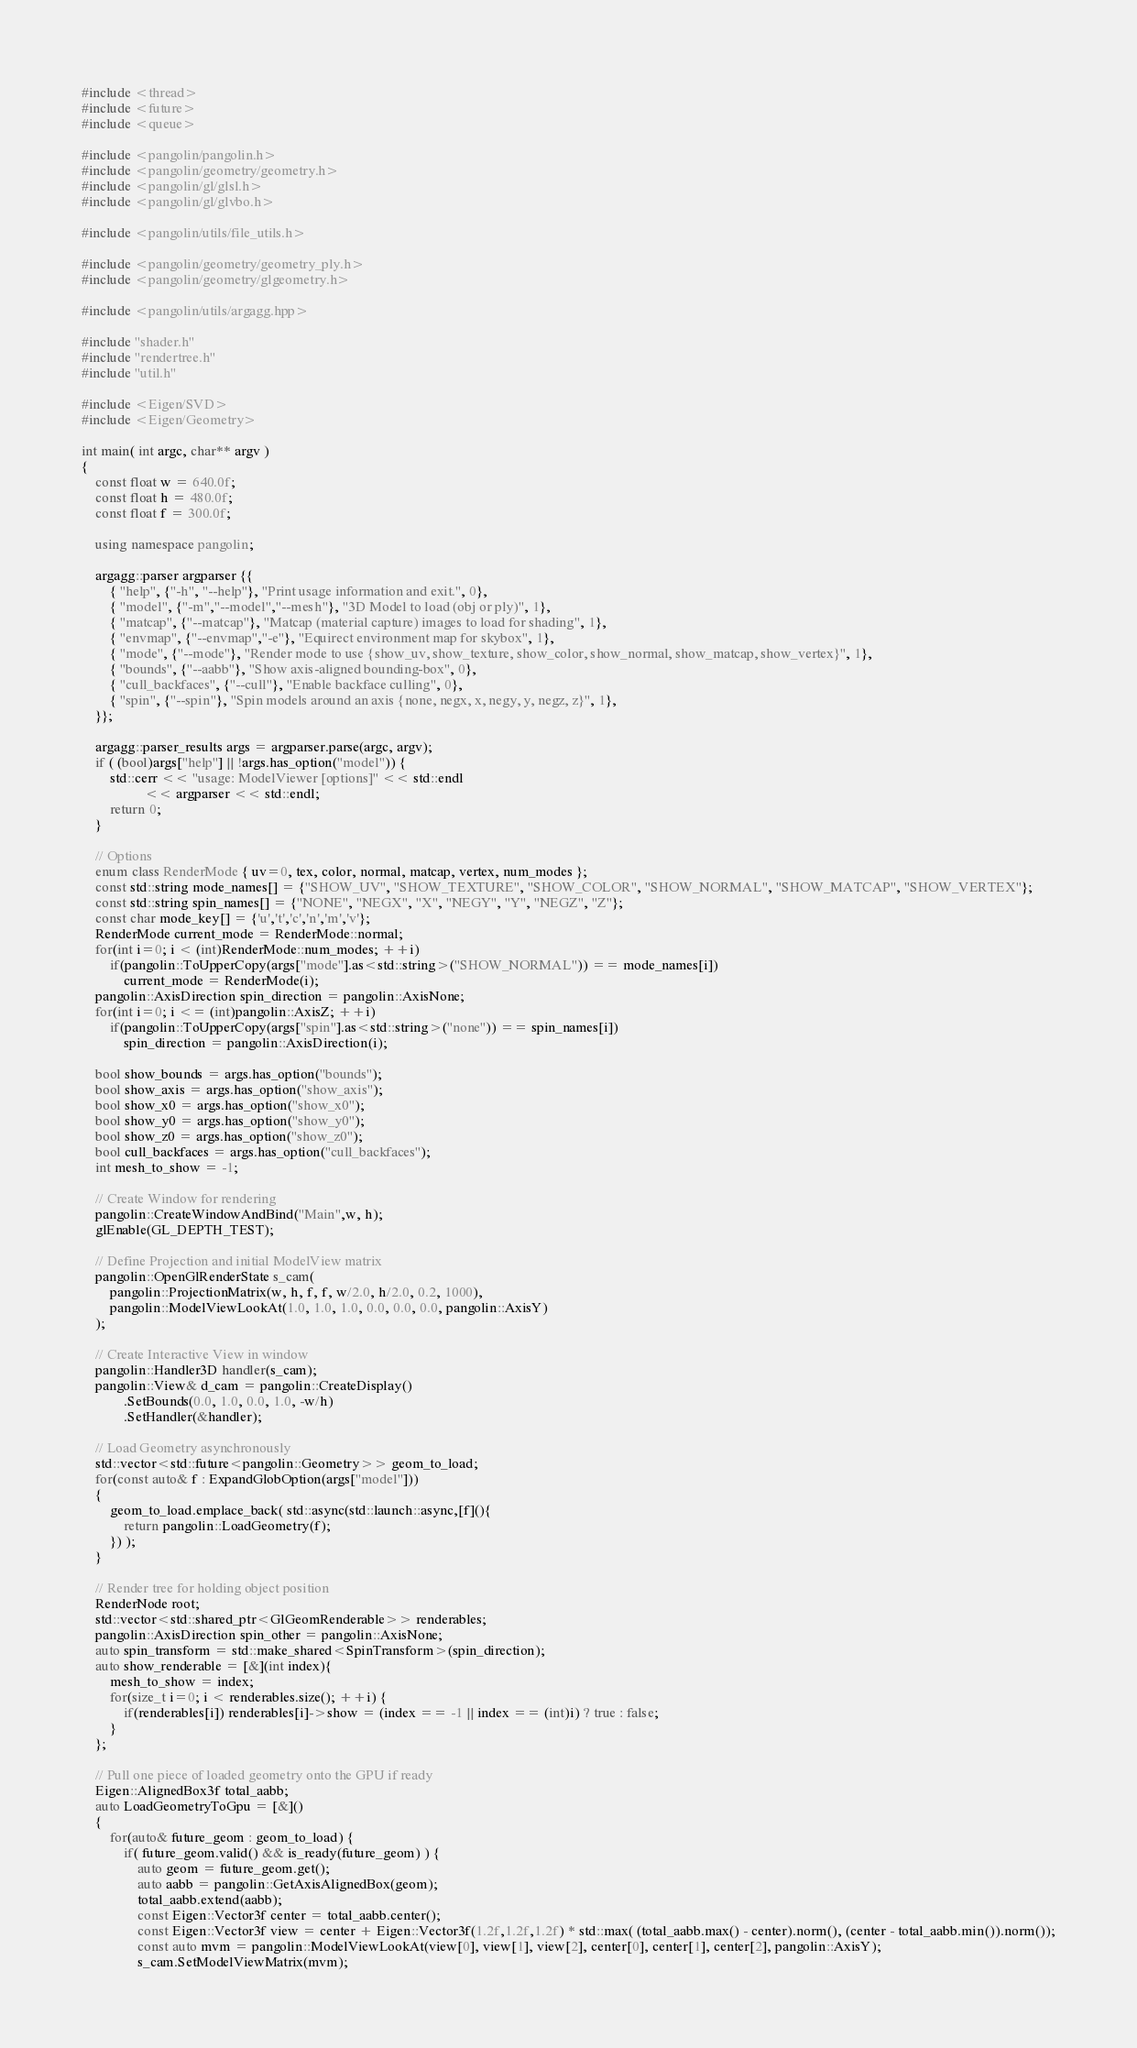<code> <loc_0><loc_0><loc_500><loc_500><_C++_>#include <thread>
#include <future>
#include <queue>

#include <pangolin/pangolin.h>
#include <pangolin/geometry/geometry.h>
#include <pangolin/gl/glsl.h>
#include <pangolin/gl/glvbo.h>

#include <pangolin/utils/file_utils.h>

#include <pangolin/geometry/geometry_ply.h>
#include <pangolin/geometry/glgeometry.h>

#include <pangolin/utils/argagg.hpp>

#include "shader.h"
#include "rendertree.h"
#include "util.h"

#include <Eigen/SVD>
#include <Eigen/Geometry>

int main( int argc, char** argv )
{
    const float w = 640.0f;
    const float h = 480.0f;
    const float f = 300.0f;

    using namespace pangolin;

    argagg::parser argparser {{
        { "help", {"-h", "--help"}, "Print usage information and exit.", 0},
        { "model", {"-m","--model","--mesh"}, "3D Model to load (obj or ply)", 1},
        { "matcap", {"--matcap"}, "Matcap (material capture) images to load for shading", 1},
        { "envmap", {"--envmap","-e"}, "Equirect environment map for skybox", 1},
        { "mode", {"--mode"}, "Render mode to use {show_uv, show_texture, show_color, show_normal, show_matcap, show_vertex}", 1},
        { "bounds", {"--aabb"}, "Show axis-aligned bounding-box", 0},
        { "cull_backfaces", {"--cull"}, "Enable backface culling", 0},
        { "spin", {"--spin"}, "Spin models around an axis {none, negx, x, negy, y, negz, z}", 1},
    }};

    argagg::parser_results args = argparser.parse(argc, argv);
    if ( (bool)args["help"] || !args.has_option("model")) {
        std::cerr << "usage: ModelViewer [options]" << std::endl
                  << argparser << std::endl;
        return 0;
    }

    // Options
    enum class RenderMode { uv=0, tex, color, normal, matcap, vertex, num_modes };
    const std::string mode_names[] = {"SHOW_UV", "SHOW_TEXTURE", "SHOW_COLOR", "SHOW_NORMAL", "SHOW_MATCAP", "SHOW_VERTEX"};
    const std::string spin_names[] = {"NONE", "NEGX", "X", "NEGY", "Y", "NEGZ", "Z"};
    const char mode_key[] = {'u','t','c','n','m','v'};
    RenderMode current_mode = RenderMode::normal;
    for(int i=0; i < (int)RenderMode::num_modes; ++i)
        if(pangolin::ToUpperCopy(args["mode"].as<std::string>("SHOW_NORMAL")) == mode_names[i])
            current_mode = RenderMode(i);
    pangolin::AxisDirection spin_direction = pangolin::AxisNone;
    for(int i=0; i <= (int)pangolin::AxisZ; ++i)
        if(pangolin::ToUpperCopy(args["spin"].as<std::string>("none")) == spin_names[i])
            spin_direction = pangolin::AxisDirection(i);

    bool show_bounds = args.has_option("bounds");
    bool show_axis = args.has_option("show_axis");
    bool show_x0 = args.has_option("show_x0");
    bool show_y0 = args.has_option("show_y0");
    bool show_z0 = args.has_option("show_z0");
    bool cull_backfaces = args.has_option("cull_backfaces");
    int mesh_to_show = -1;

    // Create Window for rendering
    pangolin::CreateWindowAndBind("Main",w, h);
    glEnable(GL_DEPTH_TEST);

    // Define Projection and initial ModelView matrix
    pangolin::OpenGlRenderState s_cam(
        pangolin::ProjectionMatrix(w, h, f, f, w/2.0, h/2.0, 0.2, 1000),
        pangolin::ModelViewLookAt(1.0, 1.0, 1.0, 0.0, 0.0, 0.0, pangolin::AxisY)
    );

    // Create Interactive View in window
    pangolin::Handler3D handler(s_cam);
    pangolin::View& d_cam = pangolin::CreateDisplay()
            .SetBounds(0.0, 1.0, 0.0, 1.0, -w/h)
            .SetHandler(&handler);

    // Load Geometry asynchronously
    std::vector<std::future<pangolin::Geometry>> geom_to_load;
    for(const auto& f : ExpandGlobOption(args["model"]))
    {
        geom_to_load.emplace_back( std::async(std::launch::async,[f](){
            return pangolin::LoadGeometry(f);
        }) );
    }

    // Render tree for holding object position
    RenderNode root;
    std::vector<std::shared_ptr<GlGeomRenderable>> renderables;
    pangolin::AxisDirection spin_other = pangolin::AxisNone;
    auto spin_transform = std::make_shared<SpinTransform>(spin_direction);
    auto show_renderable = [&](int index){
        mesh_to_show = index;
        for(size_t i=0; i < renderables.size(); ++i) {
            if(renderables[i]) renderables[i]->show = (index == -1 || index == (int)i) ? true : false;
        }
    };

    // Pull one piece of loaded geometry onto the GPU if ready
    Eigen::AlignedBox3f total_aabb;
    auto LoadGeometryToGpu = [&]()
    {
        for(auto& future_geom : geom_to_load) {
            if( future_geom.valid() && is_ready(future_geom) ) {
                auto geom = future_geom.get();
                auto aabb = pangolin::GetAxisAlignedBox(geom);
                total_aabb.extend(aabb);
                const Eigen::Vector3f center = total_aabb.center();
                const Eigen::Vector3f view = center + Eigen::Vector3f(1.2f,1.2f,1.2f) * std::max( (total_aabb.max() - center).norm(), (center - total_aabb.min()).norm());
                const auto mvm = pangolin::ModelViewLookAt(view[0], view[1], view[2], center[0], center[1], center[2], pangolin::AxisY);
                s_cam.SetModelViewMatrix(mvm);</code> 